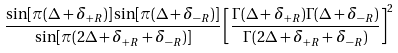Convert formula to latex. <formula><loc_0><loc_0><loc_500><loc_500>\frac { \sin [ \pi ( \Delta + \delta _ { + R } ) ] \sin [ \pi ( \Delta + \delta _ { - R } ) ] } { \sin [ \pi ( 2 \Delta + \delta _ { + R } + \delta _ { - R } ) ] } \left [ \frac { \Gamma ( \Delta + \delta _ { + R } ) \Gamma ( \Delta + \delta _ { - R } ) } { \Gamma ( 2 \Delta + \delta _ { + R } + \delta _ { - R } ) } \right ] ^ { 2 }</formula> 